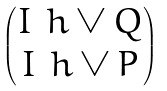Convert formula to latex. <formula><loc_0><loc_0><loc_500><loc_500>\begin{pmatrix} I _ { \ } h \vee Q \\ I _ { \ } h \vee P \end{pmatrix}</formula> 